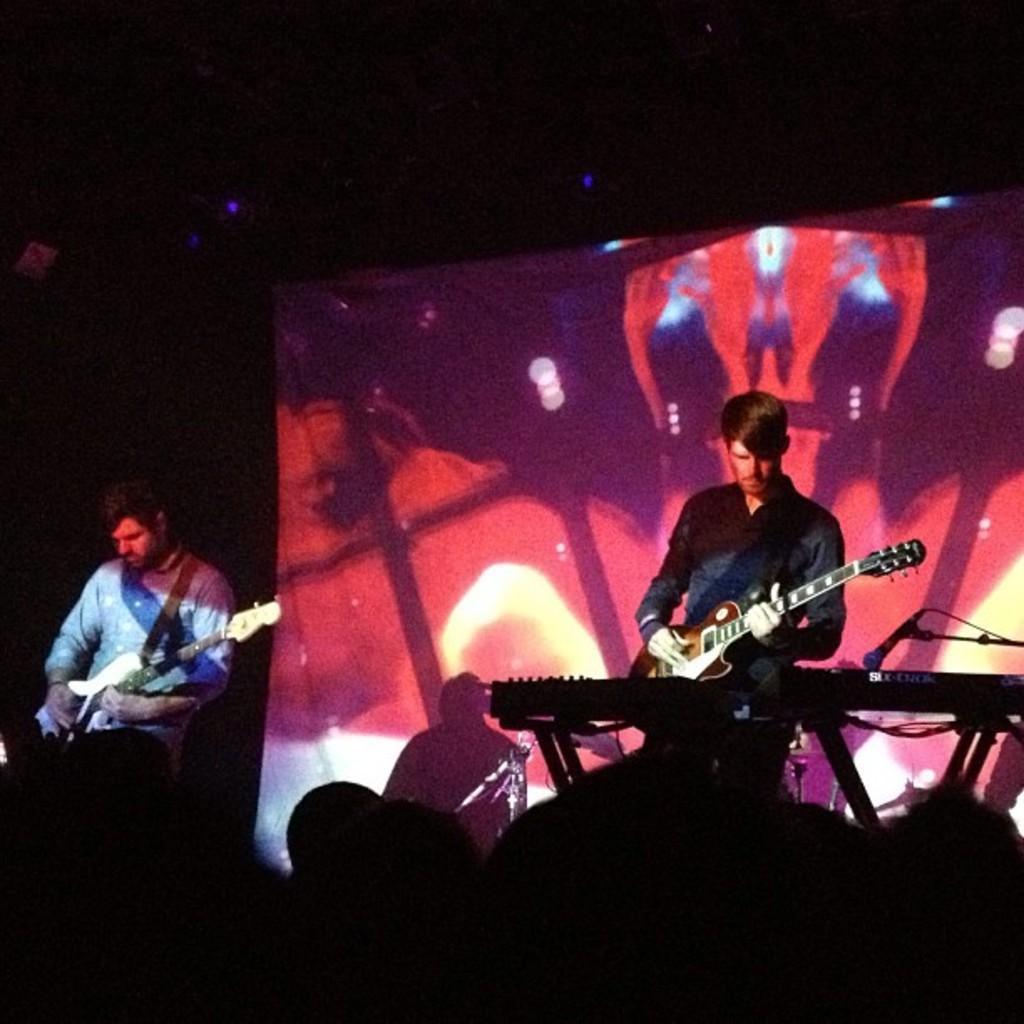Describe this image in one or two sentences. This picture is clicked in musical concert. On right corner of the picture, we see man in black shirt is holding violin in his hand and he is playing it. In front of him, we see keyboard and beside him, we see microphone. On the left corner of the picture, we see man in blue shirt is also holding violin in his hand and playing it. Behind them, we see a colorful sheet. 